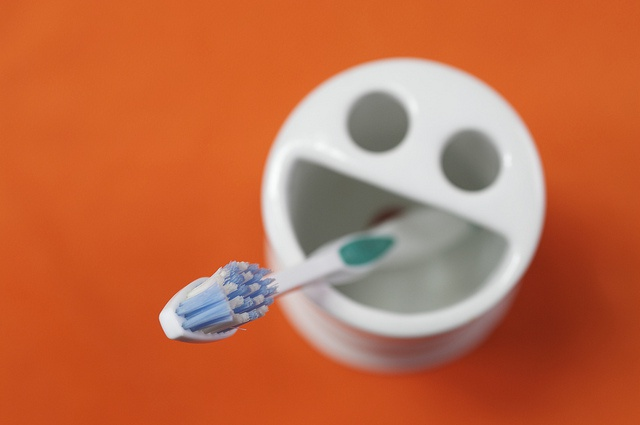Describe the objects in this image and their specific colors. I can see cup in red, lightgray, darkgray, gray, and brown tones and toothbrush in red, darkgray, lightgray, and gray tones in this image. 